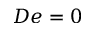Convert formula to latex. <formula><loc_0><loc_0><loc_500><loc_500>D e = 0</formula> 